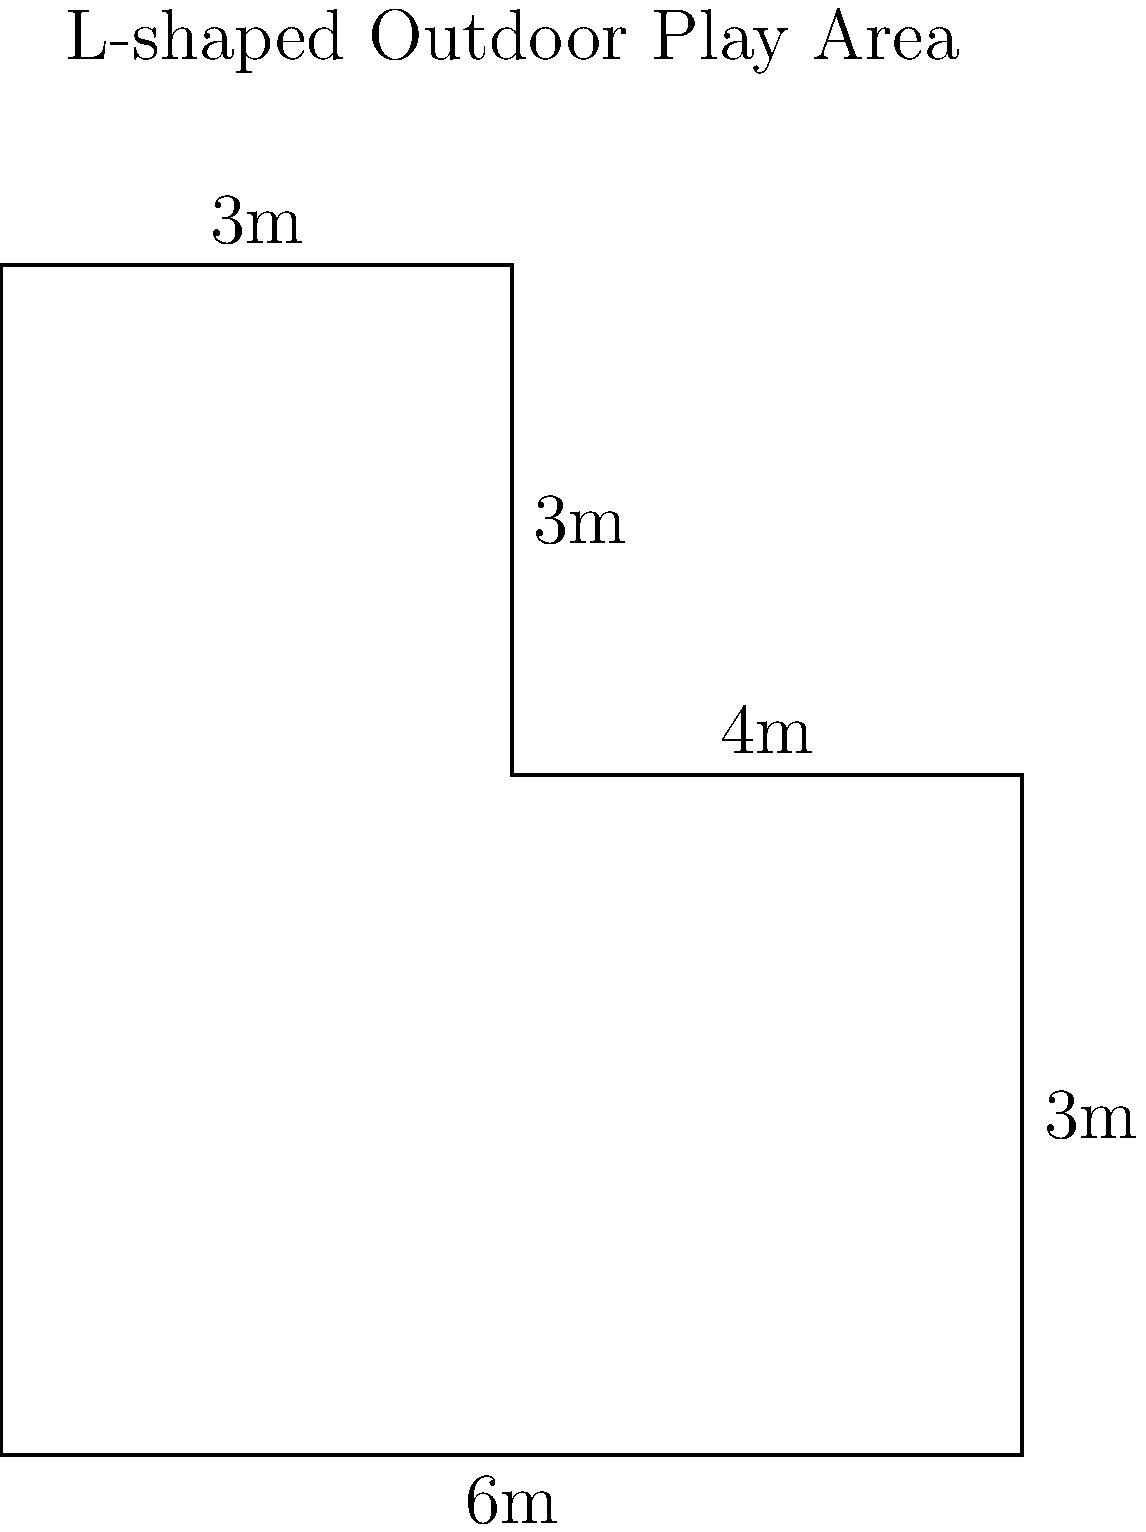As part of designing a new outdoor play area for the daycare, you need to calculate the perimeter of an L-shaped space. The play area has the following dimensions: the bottom part is 6m wide and 4m deep, while the upper part is 3m wide and extends an additional 3m in depth. What is the total perimeter of this L-shaped outdoor play area? To find the perimeter of the L-shaped play area, we need to add up all the outer edges:

1. Start with the bottom edge: $6\text{ m}$
2. Right side of the bottom part: $4\text{ m}$
3. Right side of the upper part: $3\text{ m}$
4. Top edge: $3\text{ m}$
5. Left side of the upper part: $3\text{ m}$
6. Left side of the bottom part: $4\text{ m}$

Adding all these lengths:

$$6\text{ m} + 4\text{ m} + 3\text{ m} + 3\text{ m} + 3\text{ m} + 4\text{ m} = 23\text{ m}$$

Therefore, the total perimeter of the L-shaped outdoor play area is 23 meters.
Answer: 23 m 